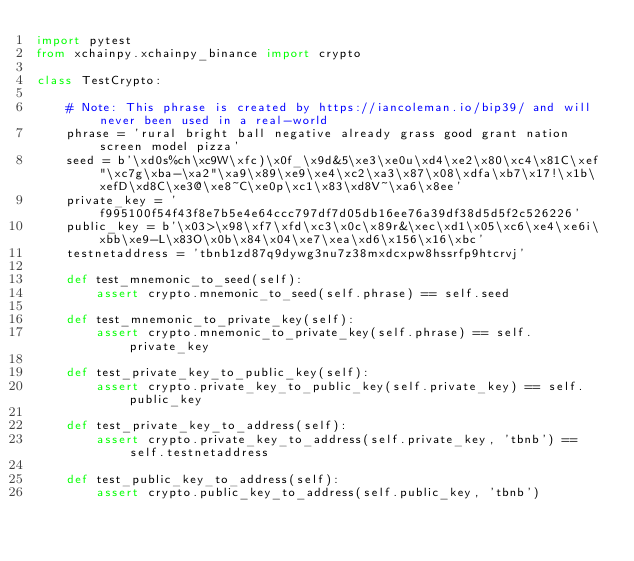<code> <loc_0><loc_0><loc_500><loc_500><_Python_>import pytest
from xchainpy.xchainpy_binance import crypto

class TestCrypto:

    # Note: This phrase is created by https://iancoleman.io/bip39/ and will never been used in a real-world
    phrase = 'rural bright ball negative already grass good grant nation screen model pizza'
    seed = b'\xd0s%ch\xc9W\xfc)\x0f_\x9d&5\xe3\xe0u\xd4\xe2\x80\xc4\x81C\xef"\xc7g\xba-\xa2"\xa9\x89\xe9\xe4\xc2\xa3\x87\x08\xdfa\xb7\x17!\x1b\xefD\xd8C\xe3@\xe8~C\xe0p\xc1\x83\xd8V~\xa6\x8ee'
    private_key = 'f995100f54f43f8e7b5e4e64ccc797df7d05db16ee76a39df38d5d5f2c526226'
    public_key = b'\x03>\x98\xf7\xfd\xc3\x0c\x89r&\xec\xd1\x05\xc6\xe4\xe6i\xbb\xe9-L\x83O\x0b\x84\x04\xe7\xea\xd6\x156\x16\xbc'
    testnetaddress = 'tbnb1zd87q9dywg3nu7z38mxdcxpw8hssrfp9htcrvj'

    def test_mnemonic_to_seed(self):
        assert crypto.mnemonic_to_seed(self.phrase) == self.seed

    def test_mnemonic_to_private_key(self):
        assert crypto.mnemonic_to_private_key(self.phrase) == self.private_key

    def test_private_key_to_public_key(self):
        assert crypto.private_key_to_public_key(self.private_key) == self.public_key

    def test_private_key_to_address(self):
        assert crypto.private_key_to_address(self.private_key, 'tbnb') == self.testnetaddress

    def test_public_key_to_address(self):
        assert crypto.public_key_to_address(self.public_key, 'tbnb')</code> 